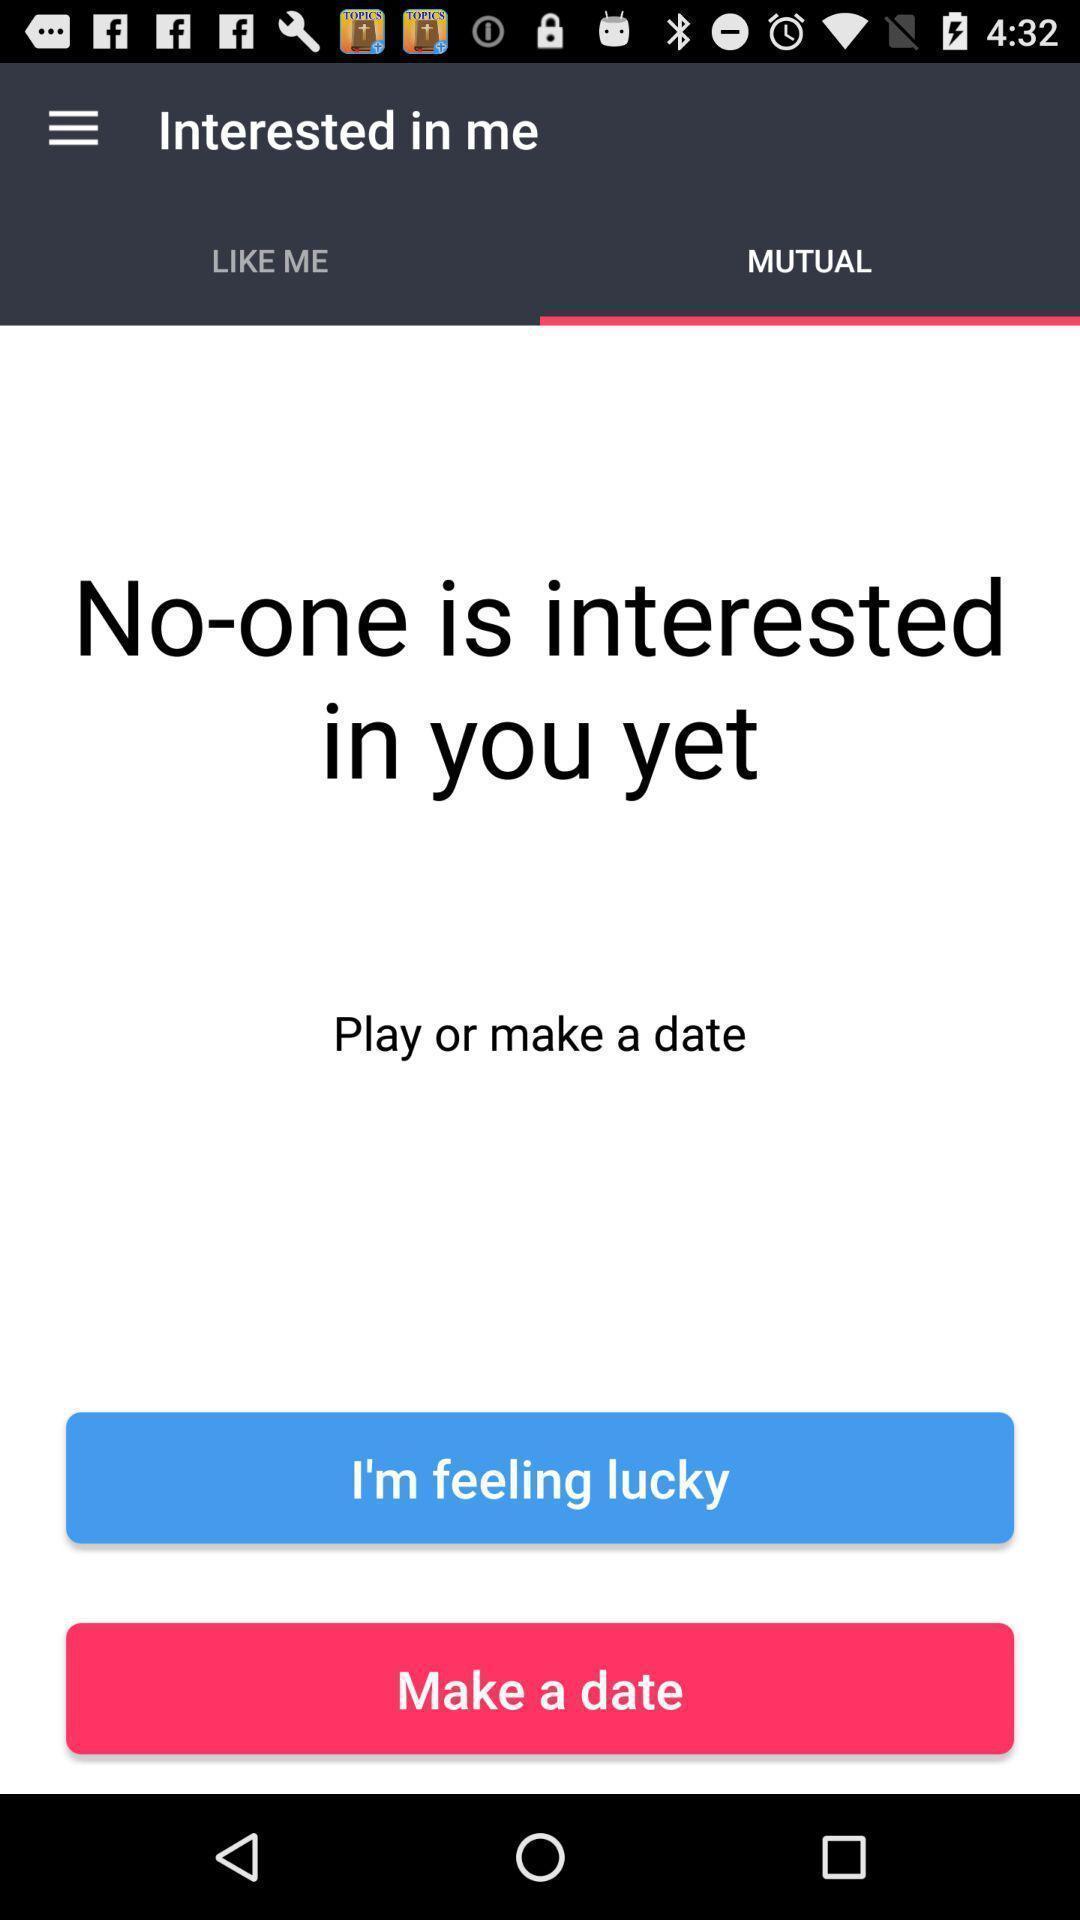Tell me what you see in this picture. Page that displaying dating application. 